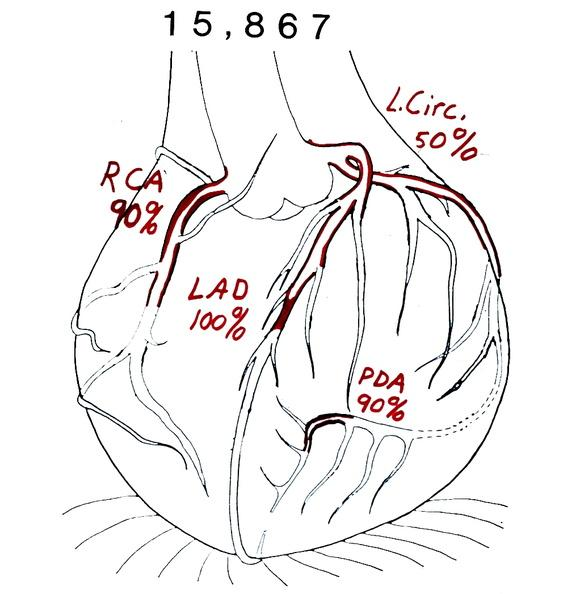what is present?
Answer the question using a single word or phrase. Cardiovascular 